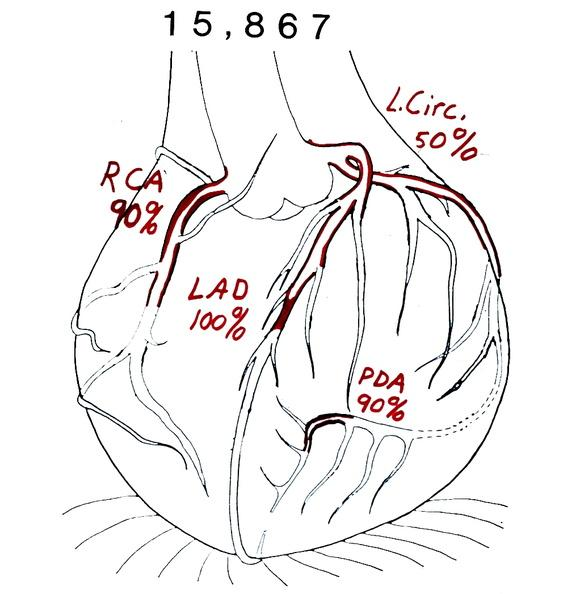what is present?
Answer the question using a single word or phrase. Cardiovascular 